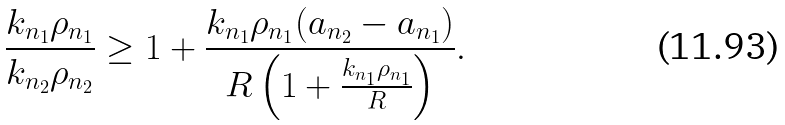Convert formula to latex. <formula><loc_0><loc_0><loc_500><loc_500>\frac { k _ { n _ { 1 } } \rho _ { n _ { 1 } } } { k _ { n _ { 2 } } \rho _ { n _ { 2 } } } \geq 1 + \frac { k _ { n _ { 1 } } \rho _ { n _ { 1 } } ( a _ { n _ { 2 } } - a _ { n _ { 1 } } ) } { R \left ( 1 + \frac { k _ { n _ { 1 } } \rho _ { n _ { 1 } } } { R } \right ) } .</formula> 